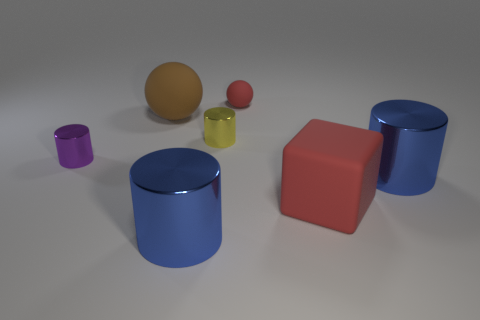Are there more big matte balls that are behind the tiny red ball than purple shiny cylinders?
Your response must be concise. No. What number of big metal objects have the same color as the large rubber cube?
Your answer should be very brief. 0. What number of other things are the same color as the small ball?
Ensure brevity in your answer.  1. Is the number of tiny yellow objects greater than the number of large gray cylinders?
Your answer should be very brief. Yes. What is the material of the large sphere?
Give a very brief answer. Rubber. There is a red rubber object in front of the yellow metal object; does it have the same size as the yellow object?
Ensure brevity in your answer.  No. There is a red matte object that is behind the yellow metal cylinder; what size is it?
Provide a short and direct response. Small. Is there anything else that is the same material as the yellow thing?
Your answer should be compact. Yes. What number of shiny objects are there?
Your answer should be compact. 4. Does the matte cube have the same color as the large matte ball?
Your answer should be very brief. No. 